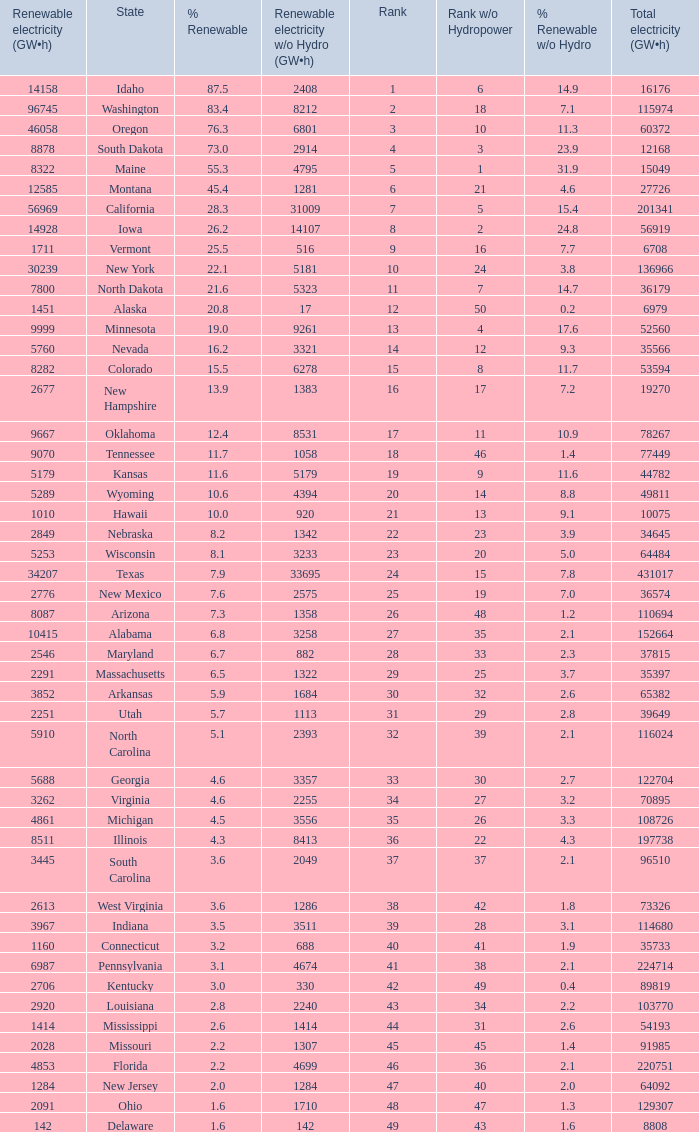Which state has 5179 (gw×h) of renewable energy without hydrogen power?wha Kansas. 